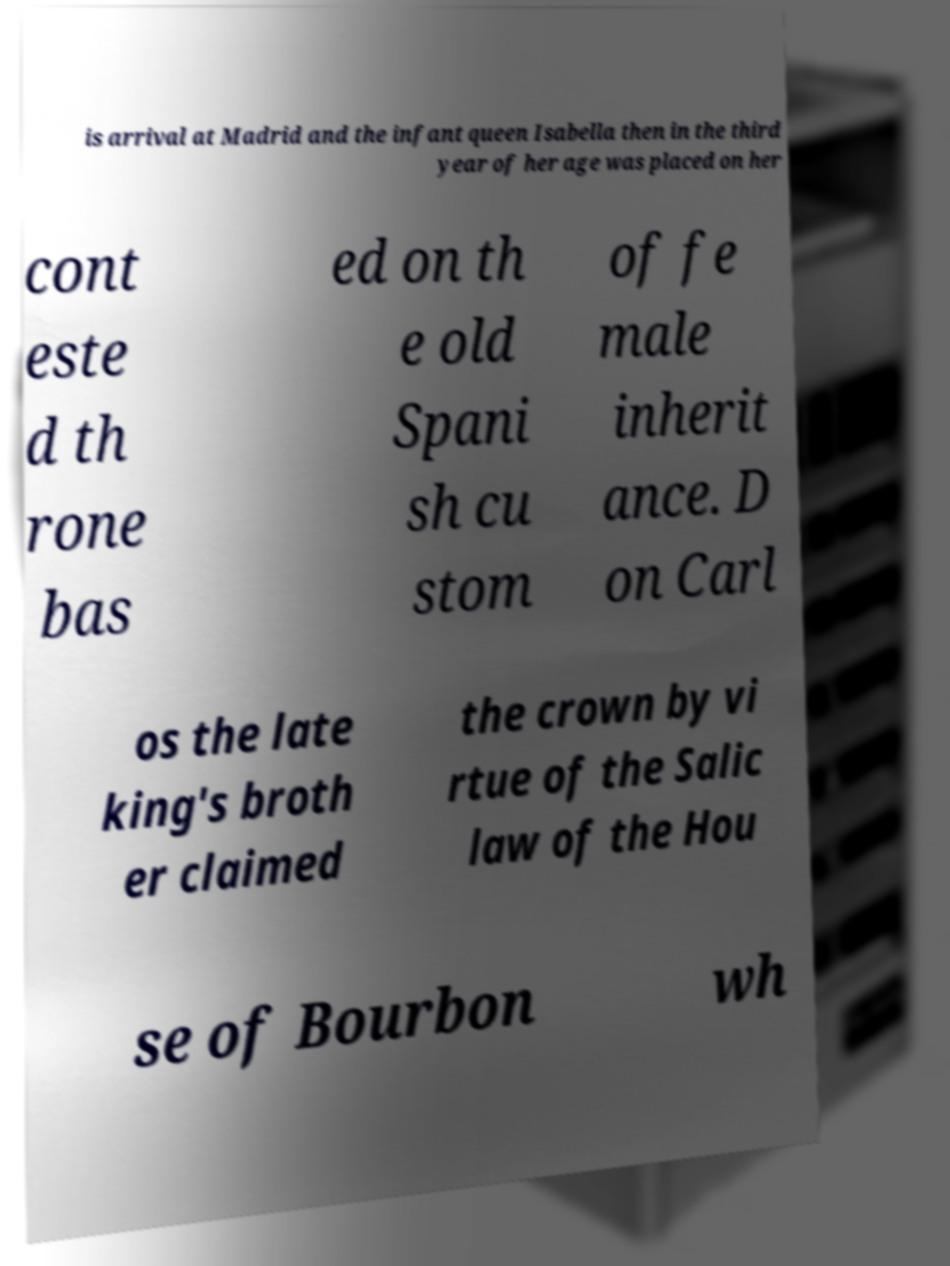Can you read and provide the text displayed in the image?This photo seems to have some interesting text. Can you extract and type it out for me? is arrival at Madrid and the infant queen Isabella then in the third year of her age was placed on her cont este d th rone bas ed on th e old Spani sh cu stom of fe male inherit ance. D on Carl os the late king's broth er claimed the crown by vi rtue of the Salic law of the Hou se of Bourbon wh 